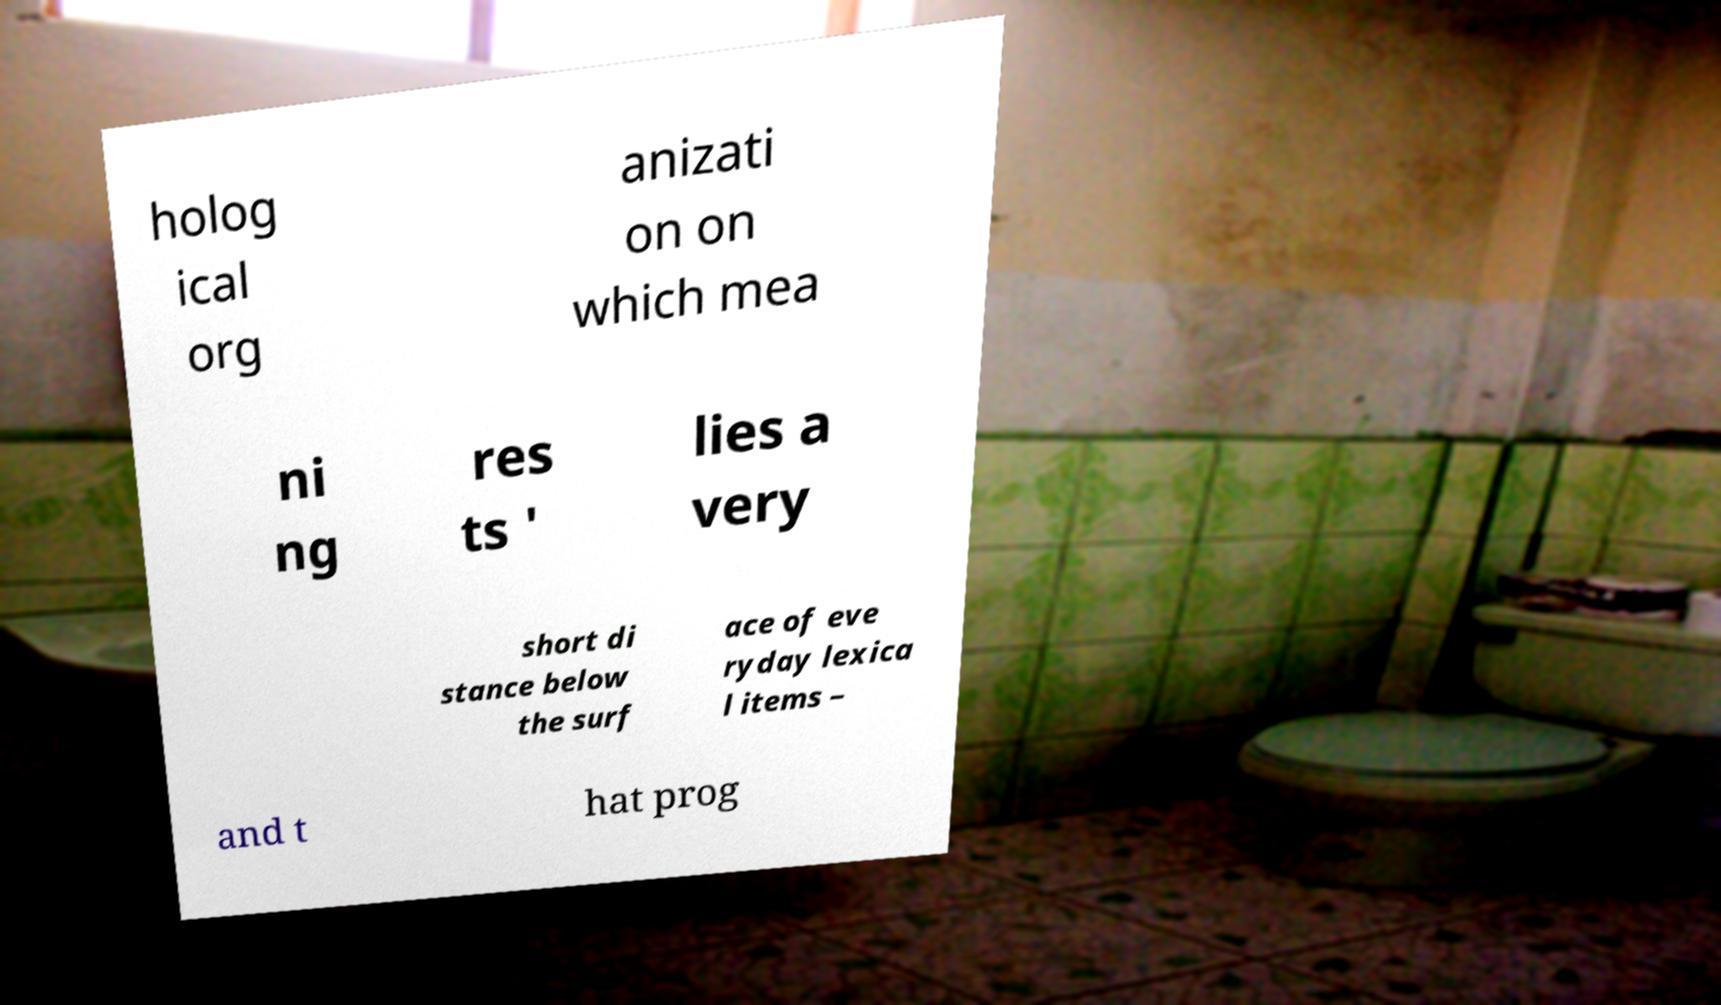Can you read and provide the text displayed in the image?This photo seems to have some interesting text. Can you extract and type it out for me? holog ical org anizati on on which mea ni ng res ts ' lies a very short di stance below the surf ace of eve ryday lexica l items – and t hat prog 